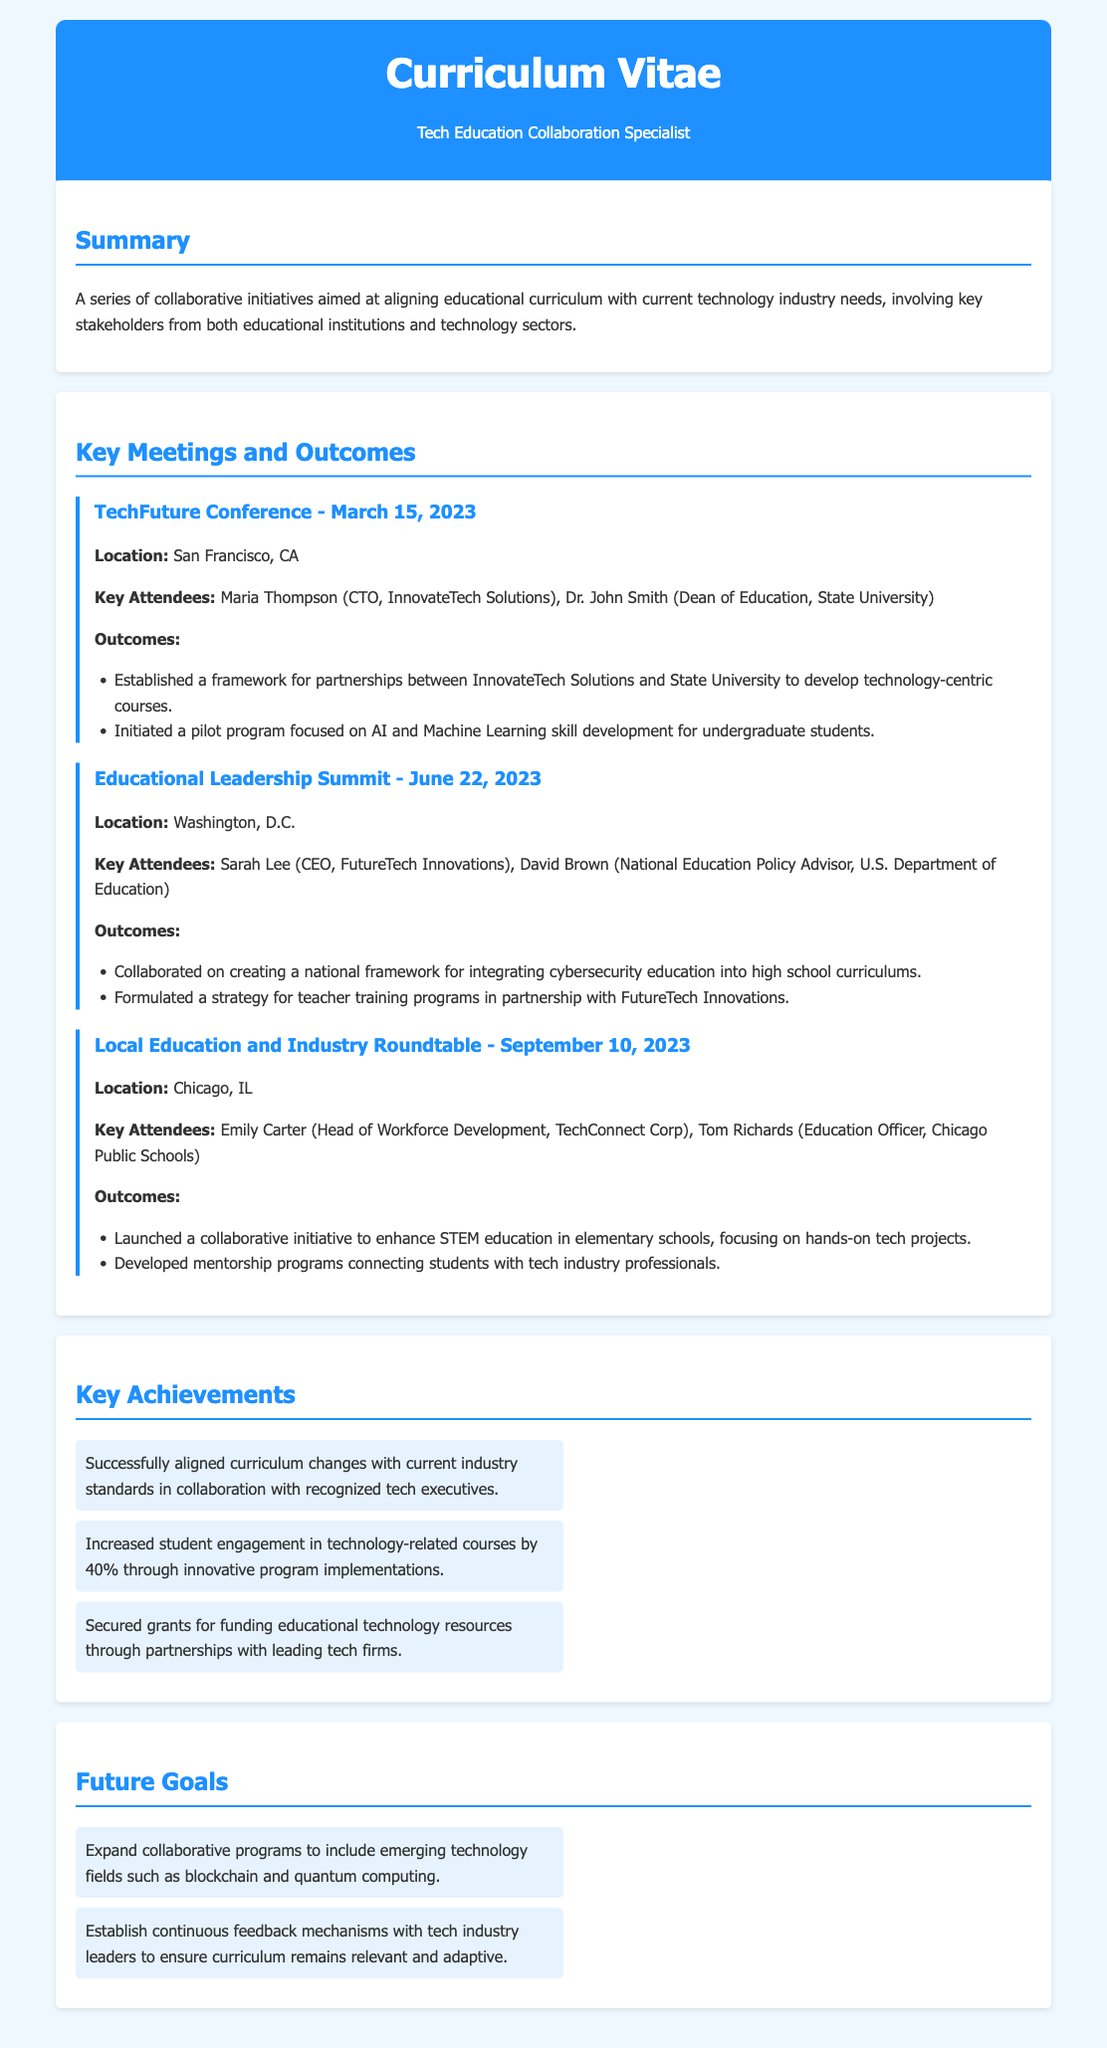What was the location of the TechFuture Conference? The location for the TechFuture Conference is provided in the meeting section of the document as San Francisco, CA.
Answer: San Francisco, CA Who attended the Educational Leadership Summit? The key attendees of the Educational Leadership Summit include Sarah Lee (CEO, FutureTech Innovations) and David Brown (National Education Policy Advisor, U.S. Department of Education).
Answer: Sarah Lee, David Brown What was one outcome of the Local Education and Industry Roundtable? The document lists outcomes of the meeting, including the launch of a collaborative initiative to enhance STEM education in elementary schools.
Answer: Enhance STEM education in elementary schools When did the Educational Leadership Summit occur? The date of the Educational Leadership Summit is specified in the document as June 22, 2023.
Answer: June 22, 2023 What is one future goal mentioned in the document? The future goals section outlines goals such as expanding collaborative programs to include emerging technology fields like blockchain and quantum computing.
Answer: Expand collaborative programs to include emerging technology fields How much did student engagement increase in technology-related courses? The document mentions that student engagement increased by 40% due to innovative program implementations.
Answer: 40% What framework was established at the TechFuture Conference? The meeting outcomes highlight the establishment of a framework for partnerships between InnovateTech Solutions and State University.
Answer: Framework for partnerships Who was the CTO at the TechFuture Conference? The document identifies Maria Thompson as the CTO of InnovateTech Solutions attending the conference.
Answer: Maria Thompson 